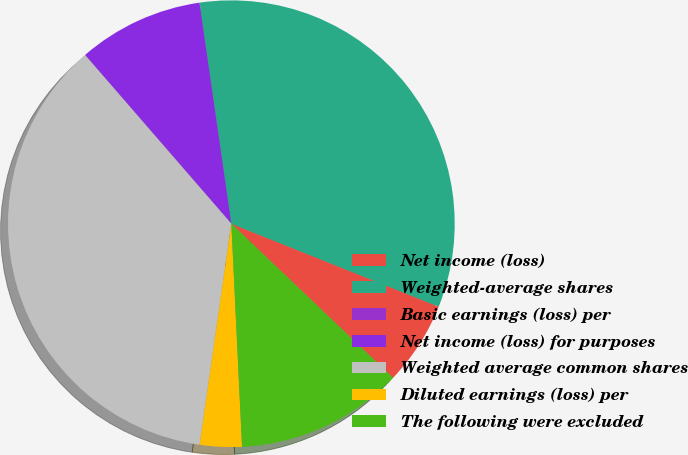Convert chart to OTSL. <chart><loc_0><loc_0><loc_500><loc_500><pie_chart><fcel>Net income (loss)<fcel>Weighted-average shares<fcel>Basic earnings (loss) per<fcel>Net income (loss) for purposes<fcel>Weighted average common shares<fcel>Diluted earnings (loss) per<fcel>The following were excluded<nl><fcel>6.06%<fcel>33.33%<fcel>0.0%<fcel>9.09%<fcel>36.36%<fcel>3.03%<fcel>12.12%<nl></chart> 